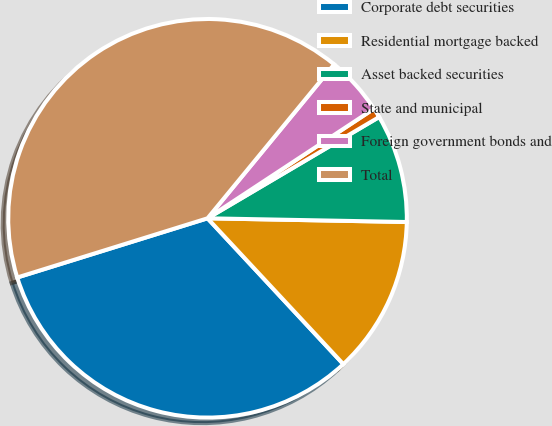Convert chart to OTSL. <chart><loc_0><loc_0><loc_500><loc_500><pie_chart><fcel>Corporate debt securities<fcel>Residential mortgage backed<fcel>Asset backed securities<fcel>State and municipal<fcel>Foreign government bonds and<fcel>Total<nl><fcel>32.13%<fcel>12.77%<fcel>8.78%<fcel>0.78%<fcel>4.78%<fcel>40.75%<nl></chart> 